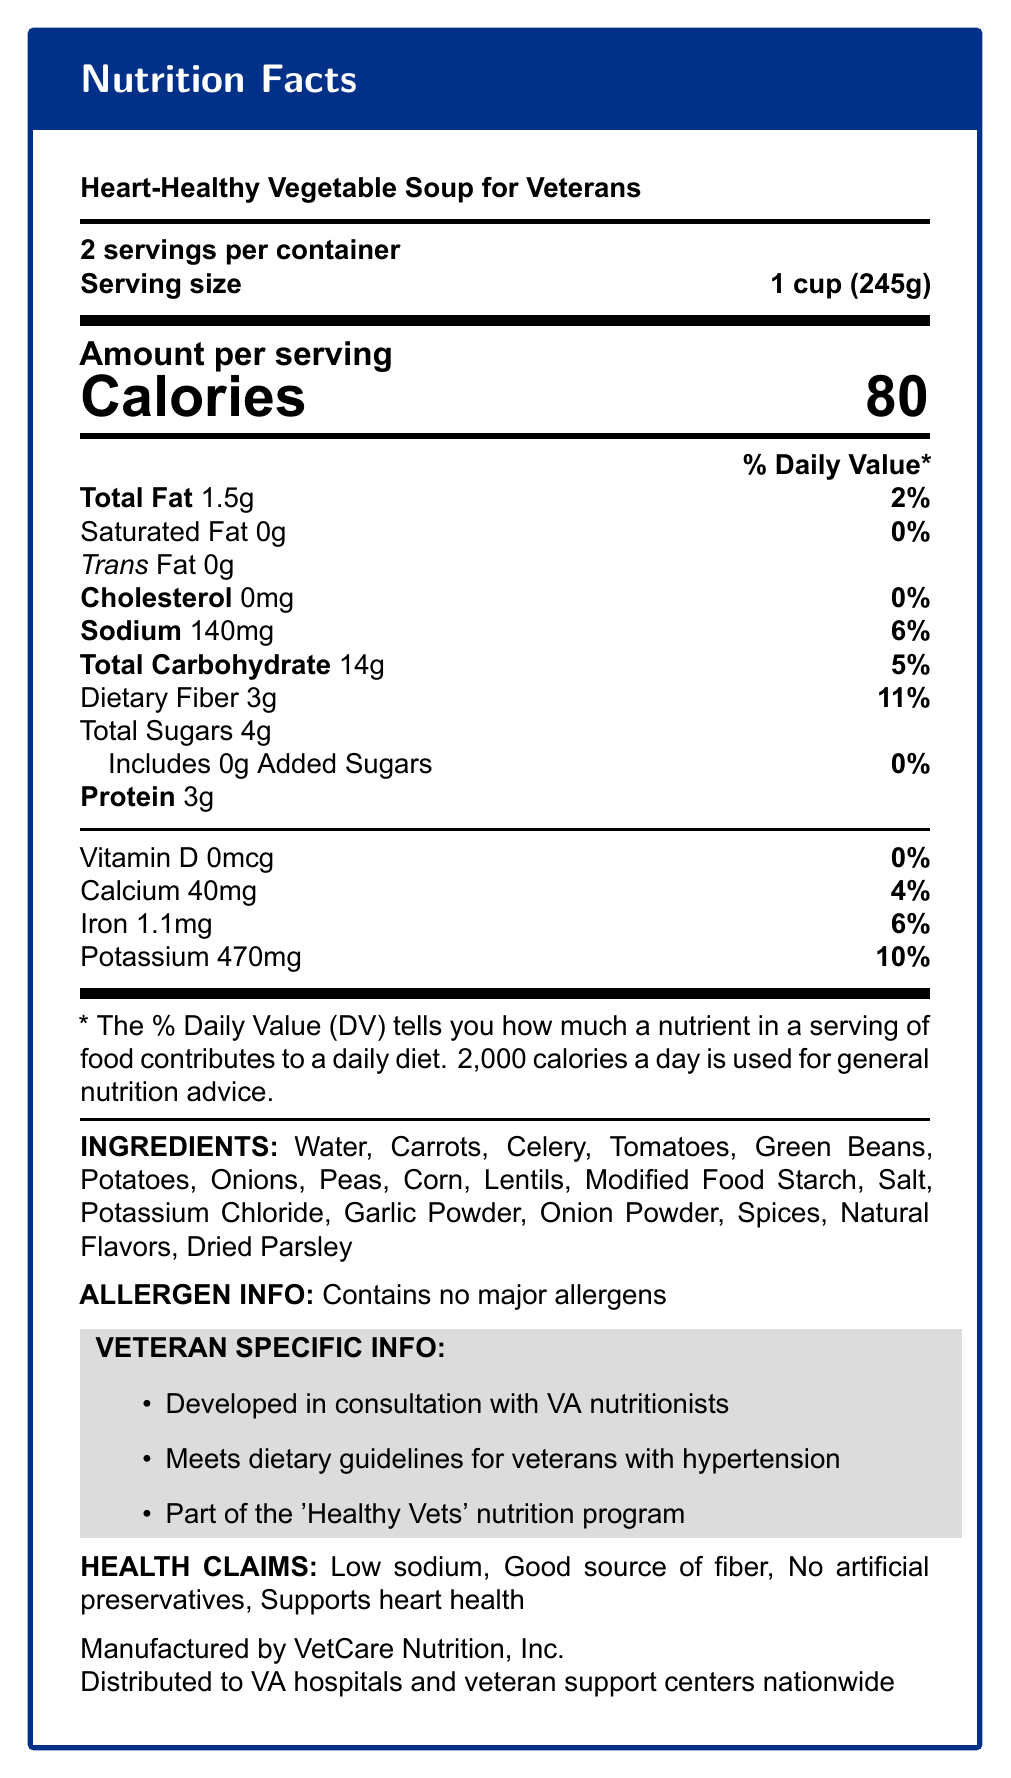what is the serving size? The serving size is specified as "1 cup (245g)" in the document.
Answer: 1 cup (245g) how many calories are in one serving? The document indicates there are 80 calories per serving.
Answer: 80 what is the total carbohydrate content per serving and its daily value percentage? Total carbohydrate per serving is 14g, which contributes 5% to the daily value.
Answer: 14g, 5% what veteran-specific information is included about the product? The veteran-specific information is listed in a dedicated section and includes these points.
Answer: Developed in consultation with VA nutritionists, Meets dietary guidelines for veterans with hypertension, Part of the 'Healthy Vets' nutrition program what is the percentage daily value of potassium per serving? The document states that the potassium content per serving contributes 10% to the daily value.
Answer: 10% what is the amount of sodium per serving? Sodium content per serving is listed as 140mg in the document.
Answer: 140mg what are the main ingredients in the "Heart-Healthy Vegetable Soup for Veterans"? The ingredients are listed in the document under the "INGREDIENTS" section.
Answer: Water, Carrots, Celery, Tomatoes, Green Beans, Potatoes, Onions, Peas, Corn, Lentils, Modified Food Starch, Salt, Potassium Chloride, Garlic Powder, Onion Powder, Spices, Natural Flavors, Dried Parsley which of the following health claims are made about the soup? A. Low sodium B. Good source of protein C. Contains artificial preservatives D. Supports heart health The health claims listed are "Low sodium" and "Supports heart health". "Good source of protein" and "Contains artificial preservatives" are not mentioned.
Answer: A, D who manufactures the Heart-Healthy Vegetable Soup for Veterans? A. Veteran Nutrition Co. B. VetCare Nutrition, Inc. C. HealthCare Solutions D. US Veterans Nutrition LLC The manufacturer is listed as VetCare Nutrition, Inc.
Answer: B is there any cholesterol in the soup? The nutrition information indicates that the cholesterol content is 0mg per serving (0% daily value).
Answer: No does the soup contain any major allergens? The allergen information states that the product contains no major allergens.
Answer: No describe the main purpose and target audience of the "Heart-Healthy Vegetable Soup for Veterans". The document clearly indicates that the product is developed in consultation with VA nutritionists and aims to meet dietary guidelines for veterans with hypertension. It is part of a broader nutrition program tailored for veterans.
Answer: The Heart-Healthy Vegetable Soup is specifically designed for veterans, particularly those with hypertension. It offers a low-sodium, heart-healthy option that aligns with dietary guidelines provided by VA nutritionists. The product is part of the 'Healthy Vets' nutrition program and is distributed to VA hospitals and veteran support centers nationwide. what vitamins and minerals are present in the soup? The nutrition label lists Vitamin D, Calcium, Iron, and Potassium with their respective amounts and daily values.
Answer: Vitamin D, Calcium, Iron, and Potassium how long has VetCare Nutrition, Inc. been in business? The document does not provide any information regarding the history or how long VetCare Nutrition, Inc. has been in business.
Answer: Cannot be determined what is the amount of dietary fiber per serving and its daily value percentage? The document states that there is 3g of dietary fiber per serving, contributing 11% to the daily value.
Answer: 3g, 11% 